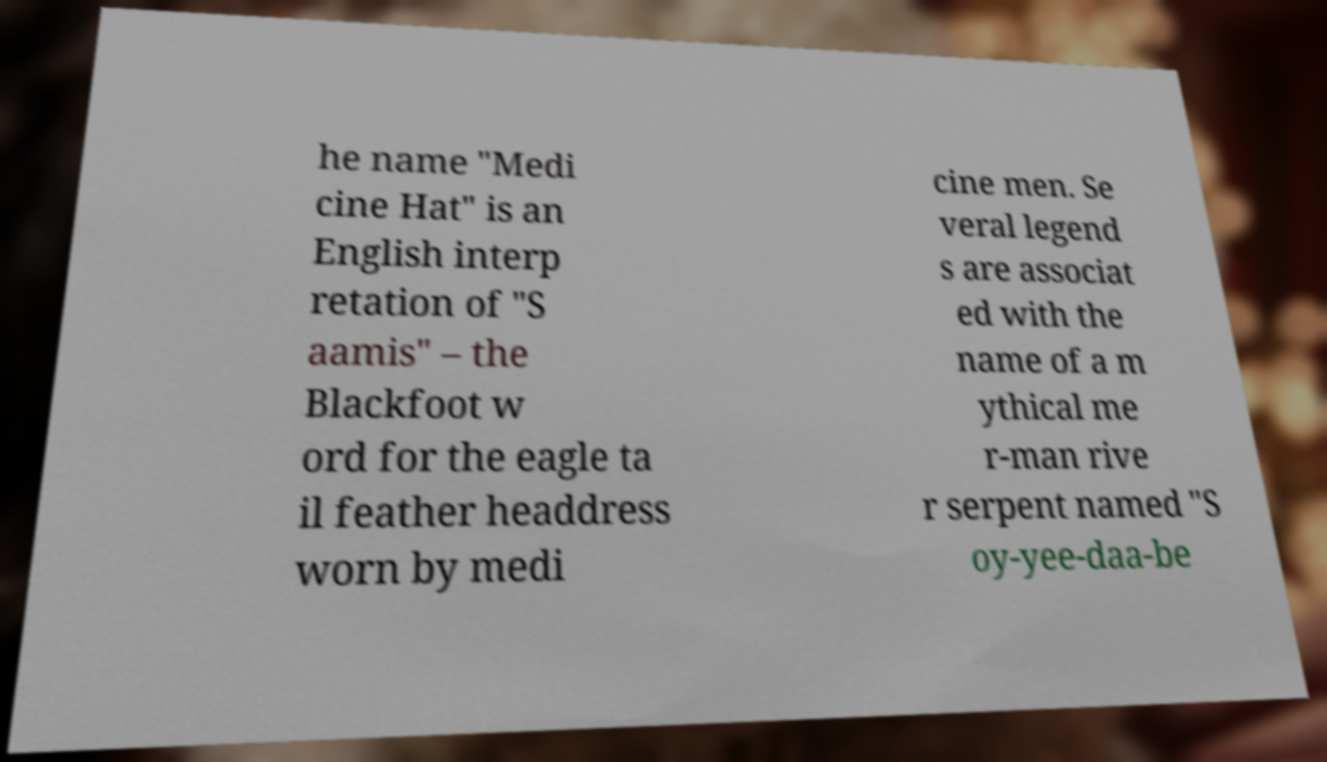What messages or text are displayed in this image? I need them in a readable, typed format. he name "Medi cine Hat" is an English interp retation of "S aamis" – the Blackfoot w ord for the eagle ta il feather headdress worn by medi cine men. Se veral legend s are associat ed with the name of a m ythical me r-man rive r serpent named "S oy-yee-daa-be 